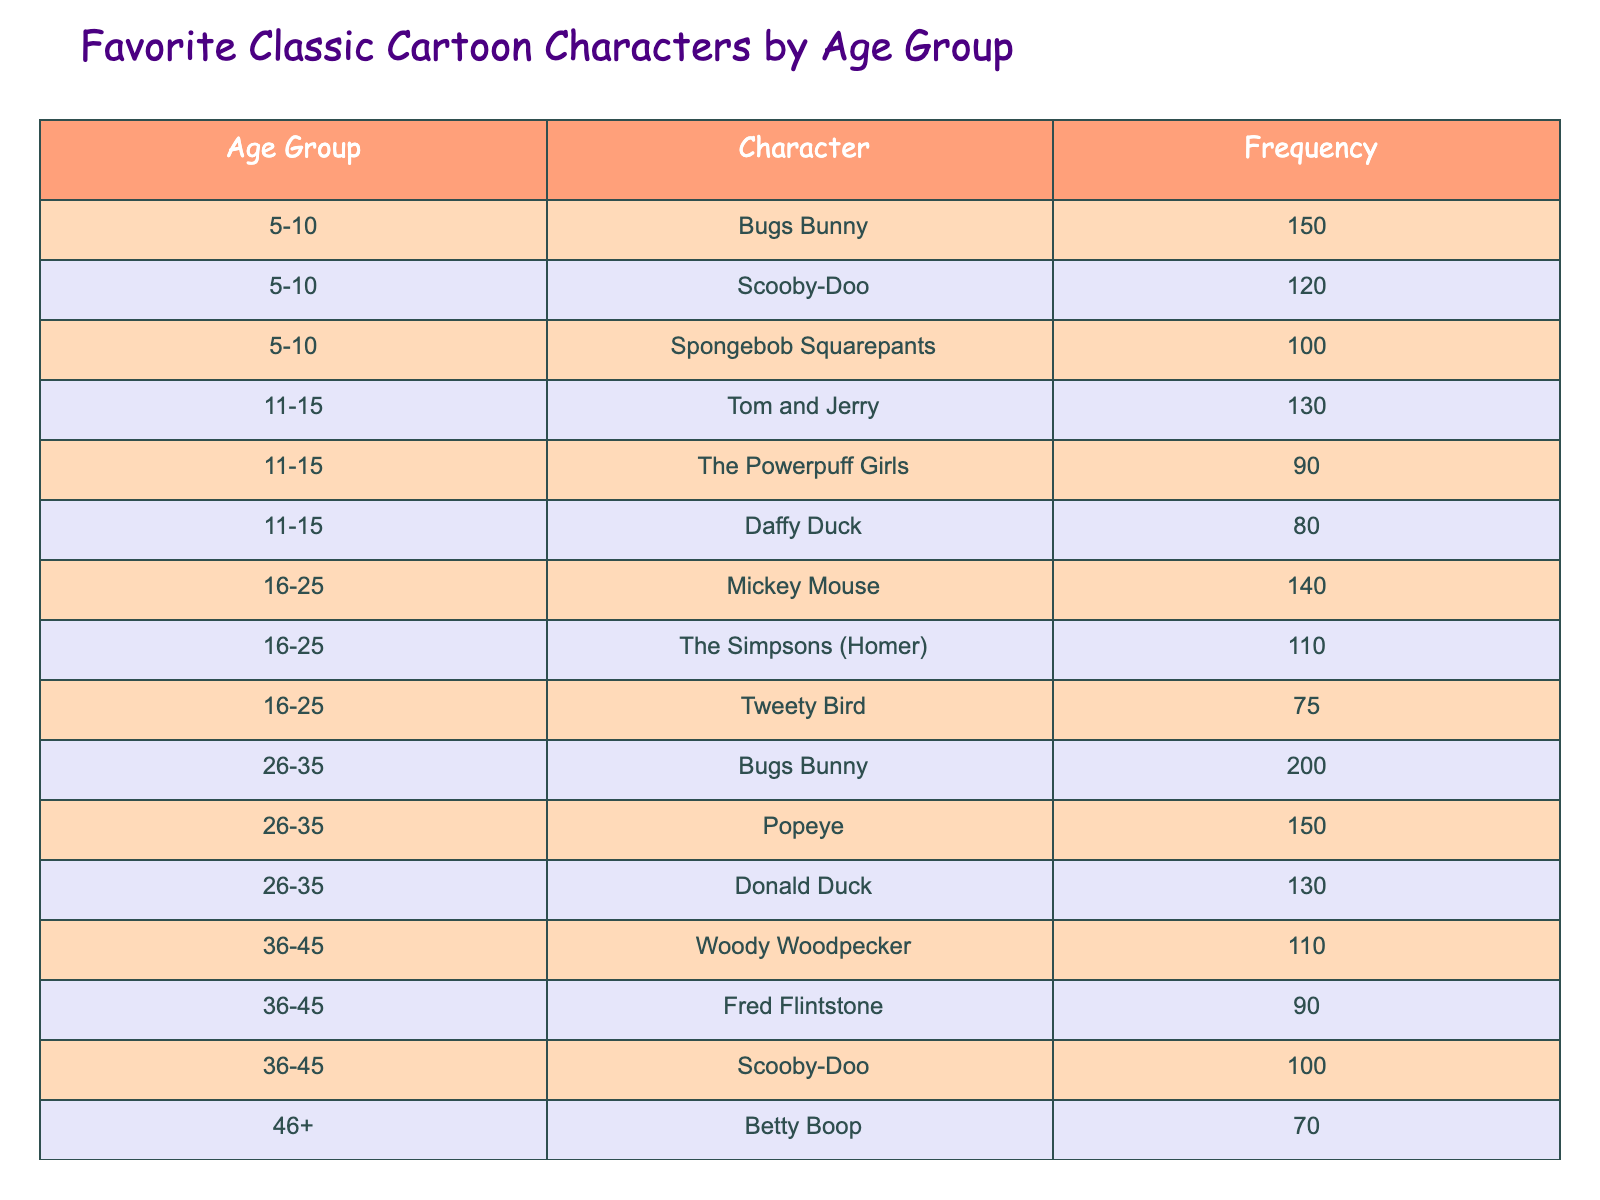What is the most popular character among the 26-35 age group? In the 26-35 age group, the character with the highest frequency is Bugs Bunny, with a count of 200.
Answer: Bugs Bunny How many people like Scooby-Doo in the 5-10 age group? Referring to the table, Scooby-Doo is liked by 120 people in the 5-10 age group.
Answer: 120 Which character has the lowest frequency in the 46+ age group? In the 46+ age group, the character with the lowest frequency is Yogi Bear, which has a count of 60.
Answer: Yogi Bear What is the total frequency of favorite characters for the 11-15 age group? For the 11-15 age group, we add the frequencies of Tom and Jerry (130), The Powerpuff Girls (90), and Daffy Duck (80), yielding a total of 130 + 90 + 80 = 300.
Answer: 300 Is Daffy Duck more liked by the 16-25 age group than the 46+ age group? In the 16-25 age group, Daffy Duck is not listed, meaning his frequency is 0. In the 46+ age group, he is not listed either, still resulting in 0. Therefore, the answer is no, as they are equal.
Answer: No What is the difference in frequency between Mickey Mouse and Bugs Bunny among the 16-25 age group? Mickey Mouse has a frequency of 140 and Bugs Bunny is not listed in the 16-25 age group, which we take to be 0. The difference is 140 - 0 = 140.
Answer: 140 Which age group has the highest total frequency of favorite characters? To determine the age group with the highest total frequency, we sum the frequencies for each: 5-10 (370), 11-15 (300), 16-25 (325), 26-35 (480), 36-45 (300), and 46+ (215). The highest total is for 26-35, with 480.
Answer: 26-35 Are there more fans of Tom and Jerry than of Mickey Mouse across all age groups combined? Tom and Jerry has a total frequency of 130 (from 11-15 age group) while Mickey Mouse has a total frequency of 140 (from 16-25 age group). Thus, Tom and Jerry has fewer fans overall across age groups.
Answer: No What is the average frequency of characters for age group 36-45? The age group 36-45 includes Woody Woodpecker (110), Fred Flintstone (90), and Scooby-Doo (100). The total frequency is 110 + 90 + 100 = 300. There are 3 characters, so the average is 300/3 = 100.
Answer: 100 